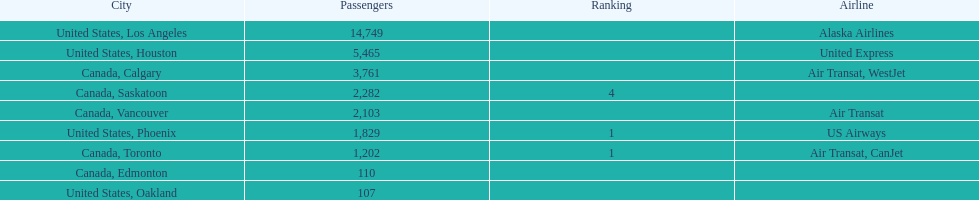What was the number of passengers in phoenix arizona? 1,829. 